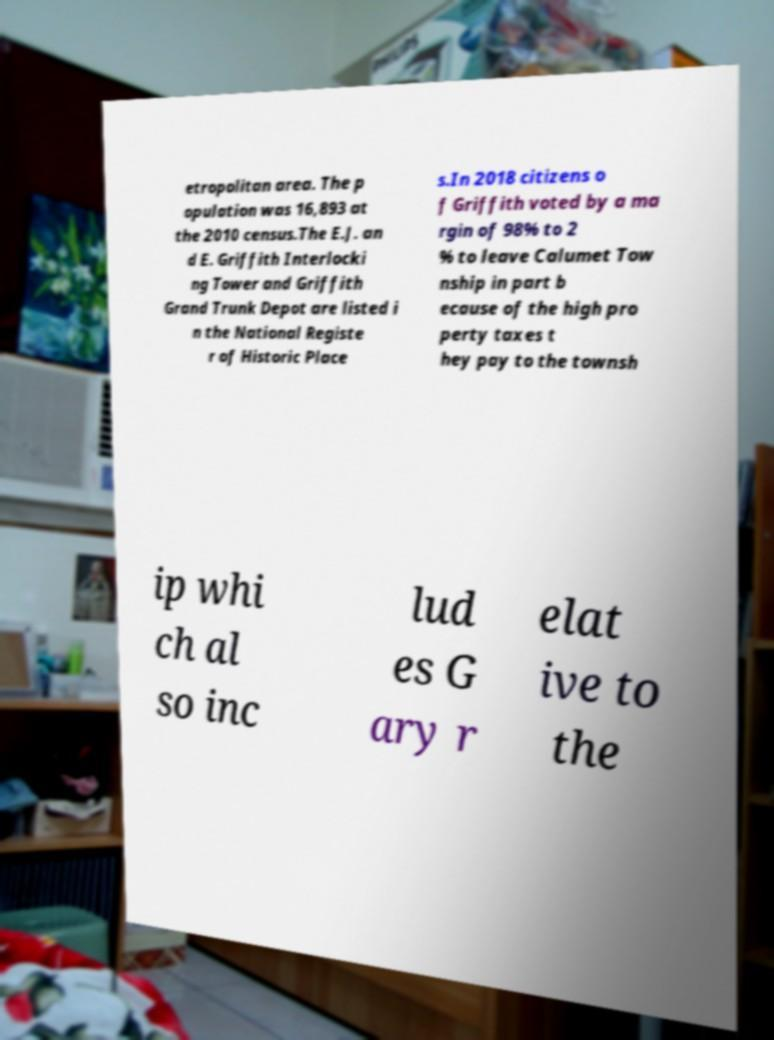Can you read and provide the text displayed in the image?This photo seems to have some interesting text. Can you extract and type it out for me? etropolitan area. The p opulation was 16,893 at the 2010 census.The E.J. an d E. Griffith Interlocki ng Tower and Griffith Grand Trunk Depot are listed i n the National Registe r of Historic Place s.In 2018 citizens o f Griffith voted by a ma rgin of 98% to 2 % to leave Calumet Tow nship in part b ecause of the high pro perty taxes t hey pay to the townsh ip whi ch al so inc lud es G ary r elat ive to the 